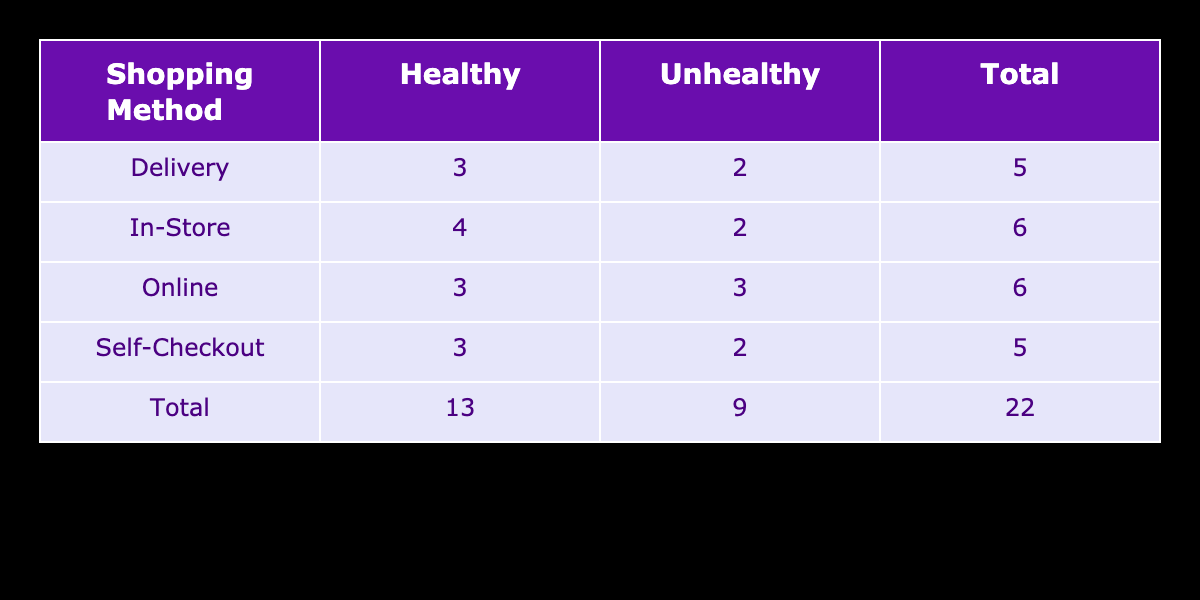What is the total number of healthy items purchased using the online method? By referring to the table, we see that there are four healthy items purchased under the online method.
Answer: 4 Which grocery shopping method has the highest number of unhealthy items purchased? Looking at the totals in the table, the Self-Checkout method has a total of three unhealthy items, which is the highest compared to In-Store, Online, and Delivery methods.
Answer: Self-Checkout What is the total number of grocery shopping methods represented in the table? The table lists four distinct grocery shopping methods: In-Store, Online, Delivery, and Self-Checkout, making a total of four methods.
Answer: 4 How many more healthy items were purchased in-store compared to from delivery? The In-Store method has five healthy items while the Delivery method has three healthy items. The difference is five minus three, which equals two.
Answer: 2 Is it true that the Online method has more unhealthy items than the In-Store method? According to the table, the Online method has three unhealthy items, while the In-Store method has two unhealthy items, so the statement is false.
Answer: No What percentage of items purchased through the Delivery method were healthy? The table shows that out of five total items in the Delivery method, three are healthy. To find the percentage, we calculate (3 healthy / 5 total) * 100, which equals 60%.
Answer: 60% If we combine all healthy items from In-Store and Self-Checkout methods, how many are there in total? The In-Store method has five healthy items, and the Self-Checkout method has three healthy items. Adding them gives us a total of five plus three, which equals eight.
Answer: 8 What is the ratio of healthy to unhealthy items for the Self-Checkout method? Referring to the table, the Self-Checkout method has three healthy items and also two unhealthy items. Therefore, the ratio of healthy to unhealthy items is 3:2.
Answer: 3:2 